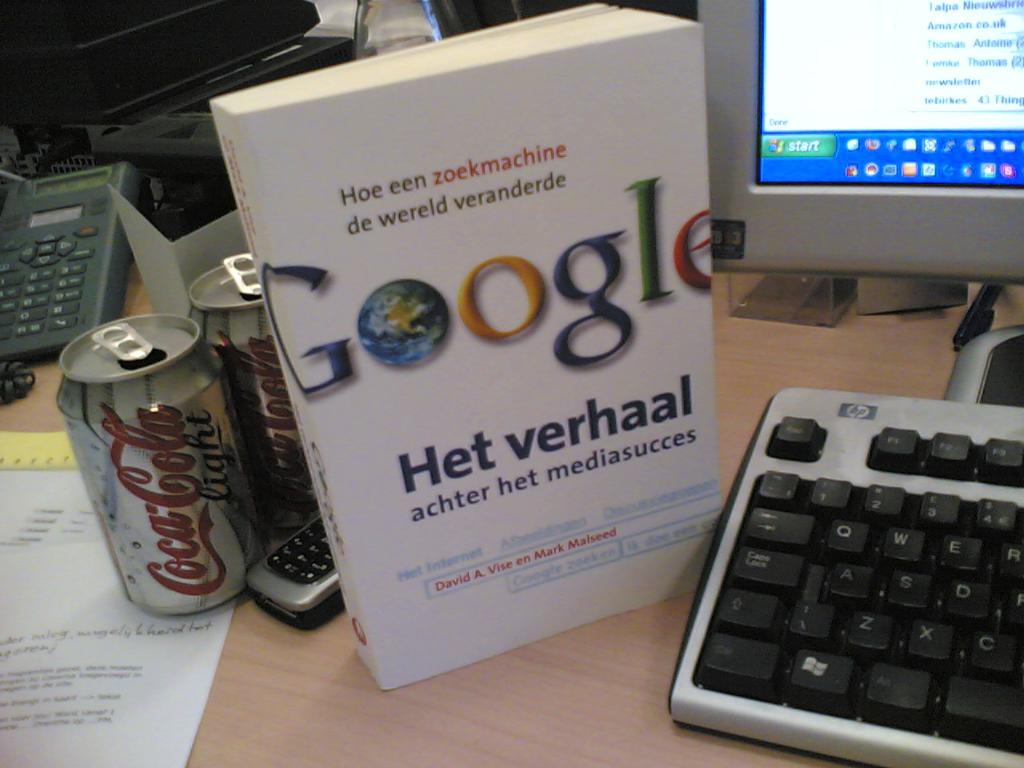Why do you think there are multiple cans of Coca Cola on the desk? The multiple cans of Coca Cola could imply the desk owner's preference for this beverage, possibly using it to stay refreshed during long sessions of study or work. It's also a nod to popular culture and the ubiquity of global brands in everyday life, perhaps serving as a comfort or a habitual drink during extended periods of concentration. 